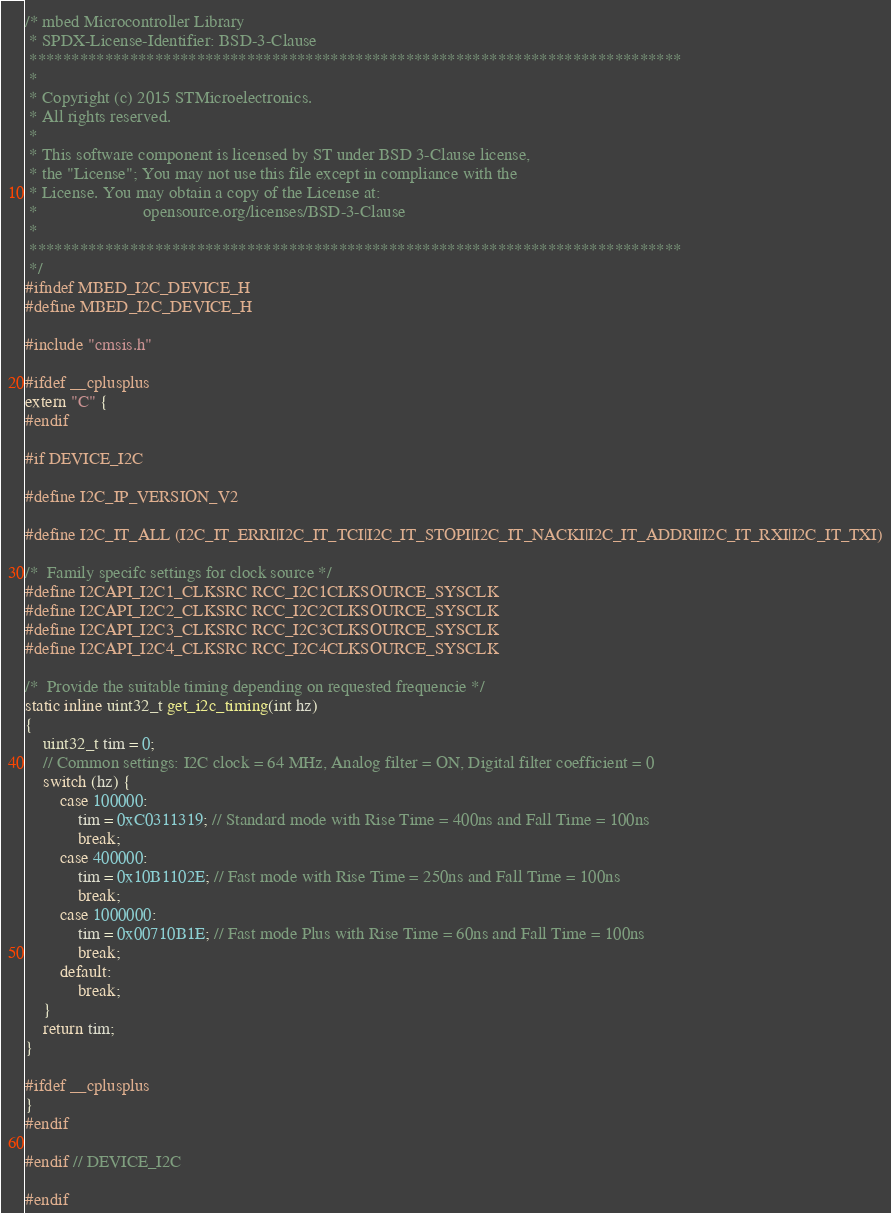Convert code to text. <code><loc_0><loc_0><loc_500><loc_500><_C_>/* mbed Microcontroller Library
 * SPDX-License-Identifier: BSD-3-Clause
 ******************************************************************************
 *
 * Copyright (c) 2015 STMicroelectronics.
 * All rights reserved.
 *
 * This software component is licensed by ST under BSD 3-Clause license,
 * the "License"; You may not use this file except in compliance with the
 * License. You may obtain a copy of the License at:
 *                        opensource.org/licenses/BSD-3-Clause
 *
 ******************************************************************************
 */
#ifndef MBED_I2C_DEVICE_H
#define MBED_I2C_DEVICE_H

#include "cmsis.h"

#ifdef __cplusplus
extern "C" {
#endif

#if DEVICE_I2C

#define I2C_IP_VERSION_V2

#define I2C_IT_ALL (I2C_IT_ERRI|I2C_IT_TCI|I2C_IT_STOPI|I2C_IT_NACKI|I2C_IT_ADDRI|I2C_IT_RXI|I2C_IT_TXI)

/*  Family specifc settings for clock source */
#define I2CAPI_I2C1_CLKSRC RCC_I2C1CLKSOURCE_SYSCLK
#define I2CAPI_I2C2_CLKSRC RCC_I2C2CLKSOURCE_SYSCLK
#define I2CAPI_I2C3_CLKSRC RCC_I2C3CLKSOURCE_SYSCLK
#define I2CAPI_I2C4_CLKSRC RCC_I2C4CLKSOURCE_SYSCLK

/*  Provide the suitable timing depending on requested frequencie */
static inline uint32_t get_i2c_timing(int hz)
{
    uint32_t tim = 0;
    // Common settings: I2C clock = 64 MHz, Analog filter = ON, Digital filter coefficient = 0
    switch (hz) {
        case 100000:
            tim = 0xC0311319; // Standard mode with Rise Time = 400ns and Fall Time = 100ns
            break;
        case 400000:
            tim = 0x10B1102E; // Fast mode with Rise Time = 250ns and Fall Time = 100ns
            break;
        case 1000000:
            tim = 0x00710B1E; // Fast mode Plus with Rise Time = 60ns and Fall Time = 100ns
            break;
        default:
            break;
    }
    return tim;
}

#ifdef __cplusplus
}
#endif

#endif // DEVICE_I2C

#endif
</code> 